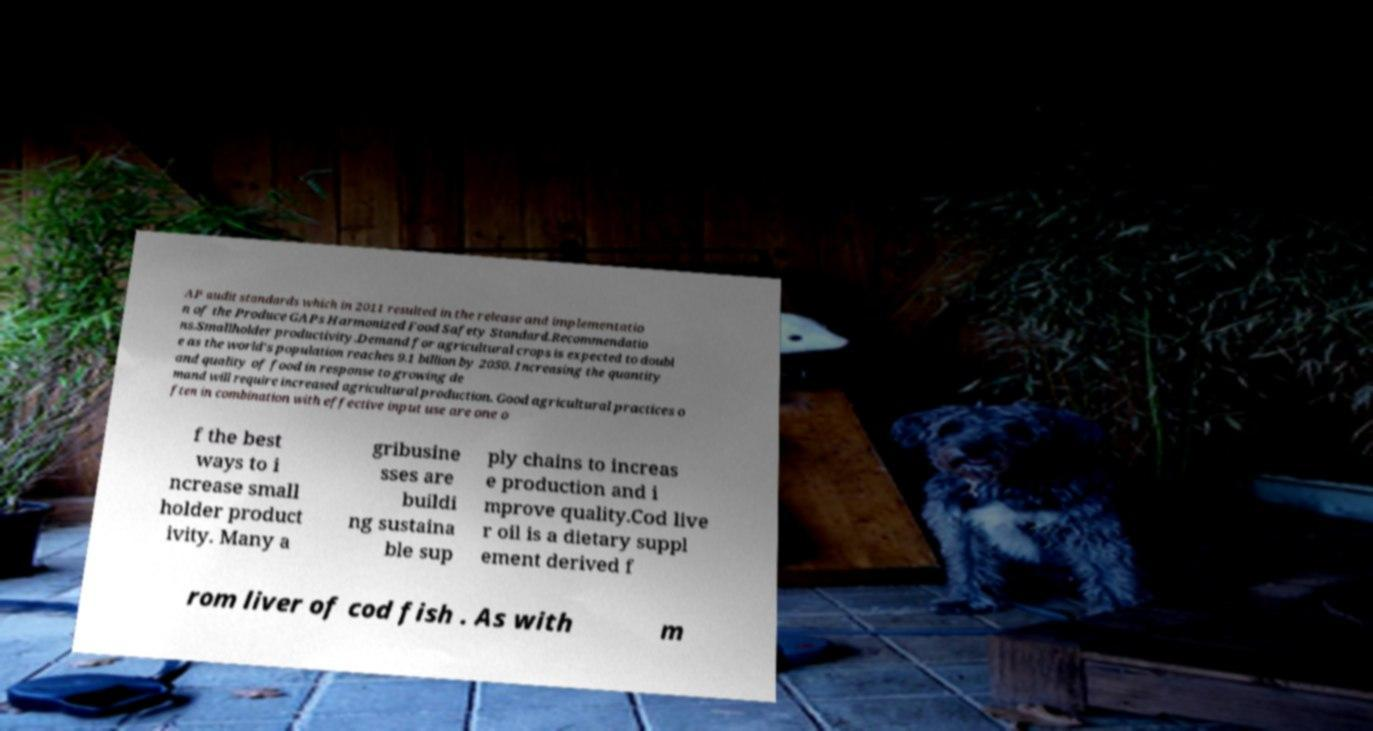For documentation purposes, I need the text within this image transcribed. Could you provide that? AP audit standards which in 2011 resulted in the release and implementatio n of the Produce GAPs Harmonized Food Safety Standard.Recommendatio ns.Smallholder productivity.Demand for agricultural crops is expected to doubl e as the world's population reaches 9.1 billion by 2050. Increasing the quantity and quality of food in response to growing de mand will require increased agricultural production. Good agricultural practices o ften in combination with effective input use are one o f the best ways to i ncrease small holder product ivity. Many a gribusine sses are buildi ng sustaina ble sup ply chains to increas e production and i mprove quality.Cod live r oil is a dietary suppl ement derived f rom liver of cod fish . As with m 